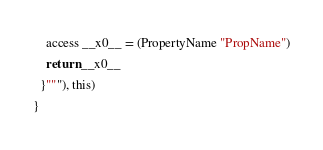Convert code to text. <code><loc_0><loc_0><loc_500><loc_500><_Scala_>    access __x0__ = (PropertyName "PropName")
    return __x0__
  }"""), this)
}
</code> 